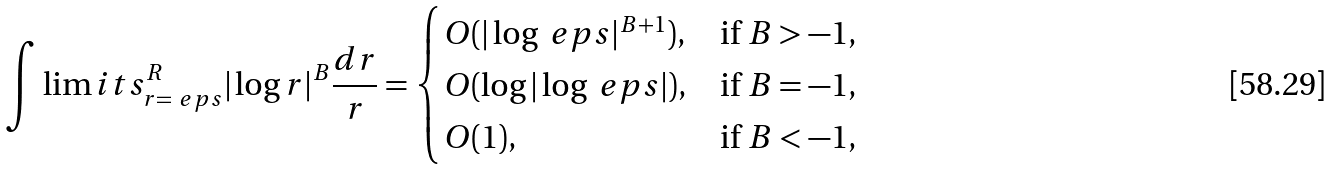<formula> <loc_0><loc_0><loc_500><loc_500>\int \lim i t s _ { r = \ e p s } ^ { R } | \log r | ^ { B } \frac { d r } { r } = \begin{cases} O ( | \log \ e p s | ^ { B + 1 } ) , & \text {if $B> -1$,} \\ O ( \log | \log \ e p s | ) , & \text {if $B=-1$,} \\ O ( 1 ) , & \text {if $B<-1$,} \end{cases}</formula> 